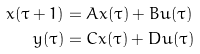<formula> <loc_0><loc_0><loc_500><loc_500>x ( \tau + 1 ) & = A x ( \tau ) + B u ( \tau ) \\ y ( \tau ) & = C x ( \tau ) + D u ( \tau )</formula> 